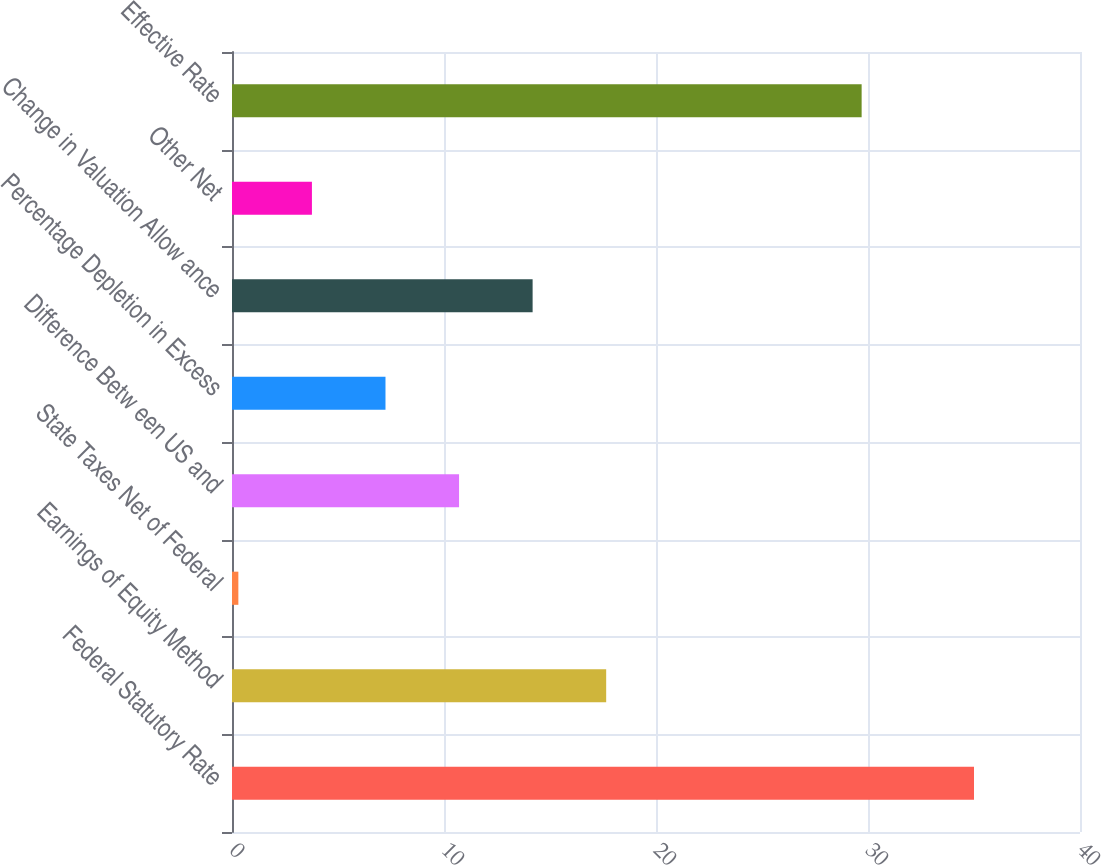<chart> <loc_0><loc_0><loc_500><loc_500><bar_chart><fcel>Federal Statutory Rate<fcel>Earnings of Equity Method<fcel>State Taxes Net of Federal<fcel>Difference Betw een US and<fcel>Percentage Depletion in Excess<fcel>Change in Valuation Allow ance<fcel>Other Net<fcel>Effective Rate<nl><fcel>35<fcel>17.65<fcel>0.3<fcel>10.71<fcel>7.24<fcel>14.18<fcel>3.77<fcel>29.7<nl></chart> 